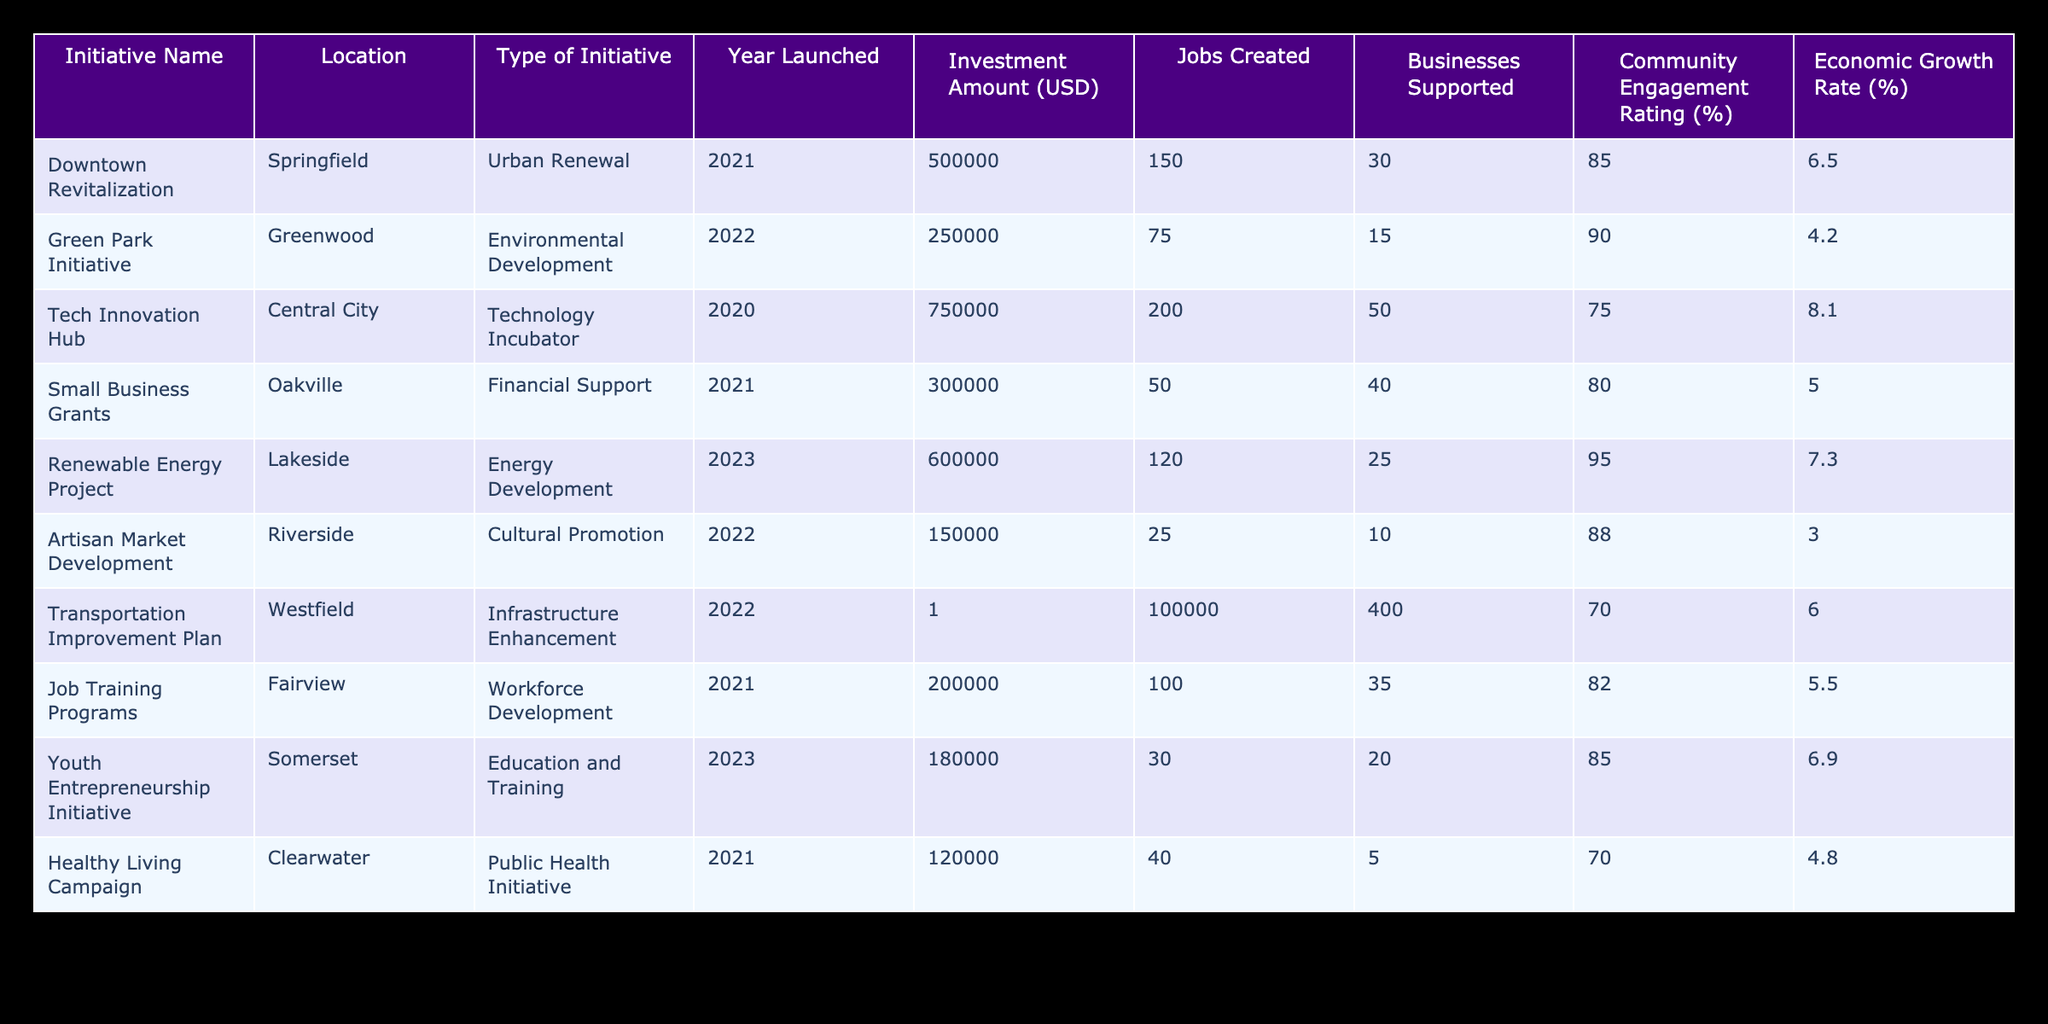What is the total investment amount across all initiatives? To find the total investment amount, sum the "Investment Amount (USD)" column values: 500000 + 250000 + 750000 + 300000 + 600000 + 150000 + 1 + 200000 + 180000 + 120000 = 2075001.
Answer: 2075001 Which initiative has the highest economic growth rate? The economic growth rates listed are: 6.5, 4.2, 8.1, 5.0, 7.3, 3.0, 6.0, 5.5, 6.9, and 4.8. The highest is 8.1 for the "Tech Innovation Hub."
Answer: Tech Innovation Hub How many jobs were created by the Downtown Revitalization initiative? The "Jobs Created" for the "Downtown Revitalization" initiative is listed directly in the table as 150.
Answer: 150 What is the average community engagement rating of all initiatives? To find the average, sum the "Community Engagement Rating (%)" values: 85 + 90 + 75 + 80 + 95 + 88 + 70 + 82 + 85 + 70 = 840. Then divide by the number of initiatives (10): 840 / 10 = 84.
Answer: 84 Did any initiative support more than 40 businesses? By examining the "Businesses Supported" column, we see the initiatives: 30, 15, 50, 40, 25, 10, 400, 35, 20, 5. The "Transportation Improvement Plan" supported 400, which is more than 40.
Answer: Yes How does the investment amount correlate with the number of jobs created for each initiative? This involves associating each initiative's investment amount with its jobs created: e.g., "Transportation Improvement Plan" has a low investment (1) but high jobs (400), while "Tech Innovation Hub" has a high investment (750000) and high jobs (200). The correlation isn’t linear; investment does not guarantee proportional job creation.
Answer: Varied correlation Which location has the lowest community engagement rating and what is the rating? The lowest community engagement rating in the table is in "Healthy Living Campaign" with a rating of 70%.
Answer: 70% (Healthy Living Campaign) Is there a significant difference in the number of jobs created between the "Small Business Grants" and the "Youth Entrepreneurship Initiative"? "Small Business Grants" created 50 jobs, while the "Youth Entrepreneurship Initiative" created 30 jobs. The difference in jobs created is 50 - 30 = 20 jobs.
Answer: 20 jobs difference What percentage of jobs created by all initiatives is attributed to the "Tech Innovation Hub"? First find the total jobs created: 150 + 75 + 200 + 50 + 120 + 25 + 400 + 100 + 30 + 40 = 890. The "Tech Innovation Hub" created 200 jobs. The percentage is (200 / 890) * 100 = 22.49%.
Answer: 22.49% 